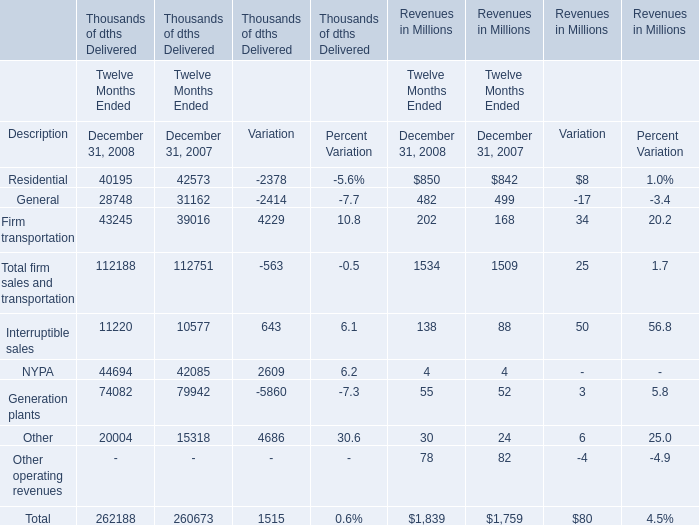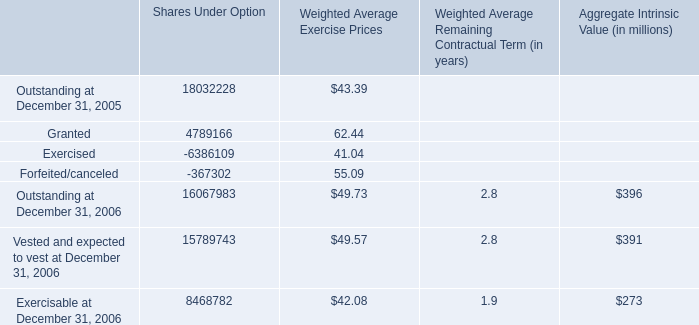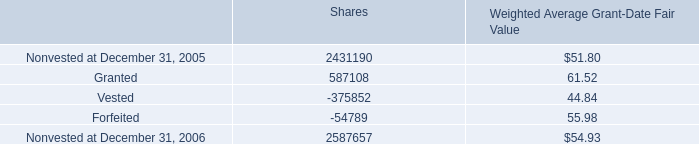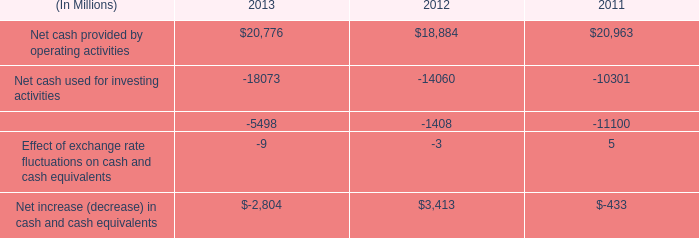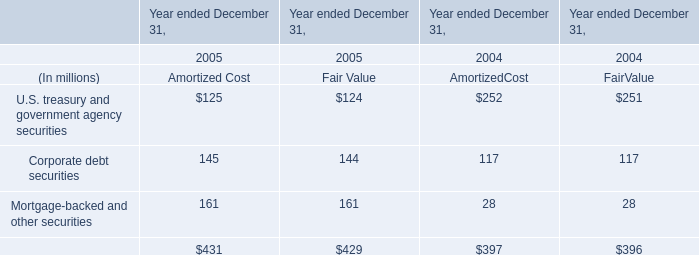What will Residential of Revenues reach in 2009 if it continues to grow at its 2008 rate? (in million) 
Computations: (850 * (1 + ((850 - 842) / 842)))
Answer: 858.07601. 